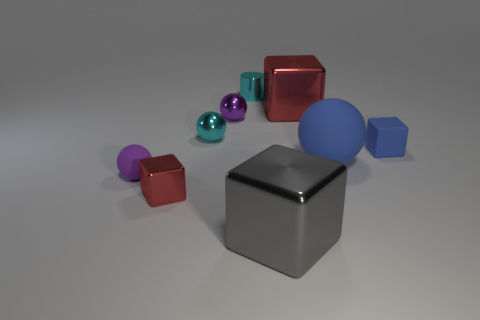Add 1 gray metal blocks. How many objects exist? 10 Subtract all balls. How many objects are left? 5 Subtract 0 blue cylinders. How many objects are left? 9 Subtract all metallic spheres. Subtract all blocks. How many objects are left? 3 Add 5 big blue objects. How many big blue objects are left? 6 Add 3 tiny spheres. How many tiny spheres exist? 6 